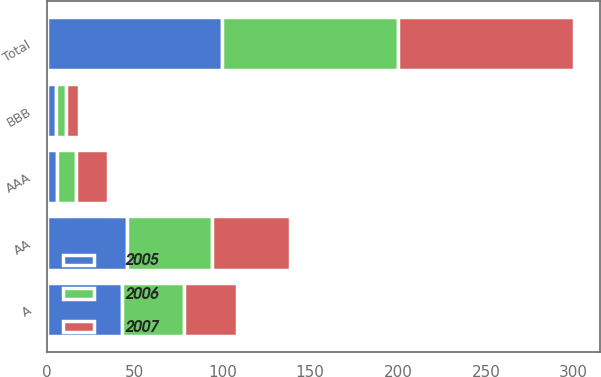Convert chart. <chart><loc_0><loc_0><loc_500><loc_500><stacked_bar_chart><ecel><fcel>AAA<fcel>AA<fcel>A<fcel>BBB<fcel>Total<nl><fcel>2007<fcel>18.4<fcel>44.1<fcel>30.2<fcel>7.3<fcel>100<nl><fcel>2006<fcel>10.6<fcel>48.9<fcel>35.1<fcel>5.4<fcel>100<nl><fcel>2005<fcel>6.1<fcel>45.5<fcel>42.9<fcel>5.5<fcel>100<nl></chart> 